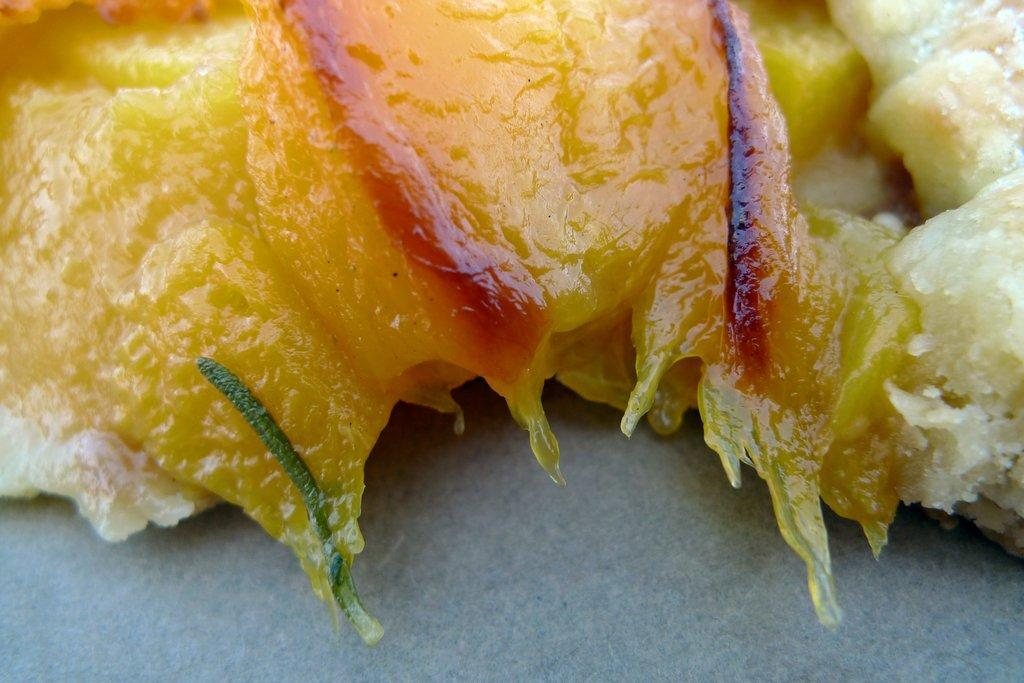What is the main subject of the image? There is a food item in the image. Can you describe the location of the food item? The food item is on a surface. What type of stocking is being used to hold the oatmeal in the image? There is no stocking or oatmeal present in the image. How many pickles can be seen in the image? There are no pickles present in the image. 